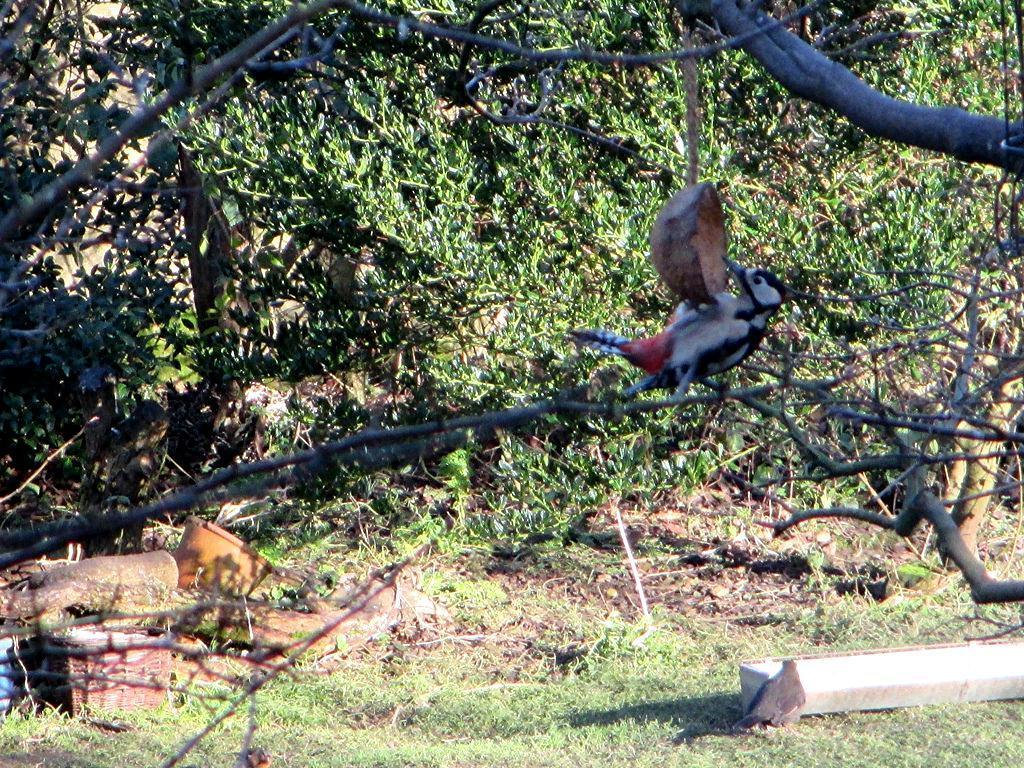What type of animals can be seen in the image? Birds can be seen in the image. What object is present in the image that could be used for carrying items? There is a basket in the image. What other unspecified objects can be seen in the image? There are unspecified objects in the image. What type of vegetation is visible in the background of the image? There are trees in the background of the image. What type of pan is being used by the birds in the image? There is no pan present in the image, and the birds are not using any pan. How many hours does it take for the birds to skate in the image? There is no skating activity involving birds in the image, and therefore no duration of time can be determined. 